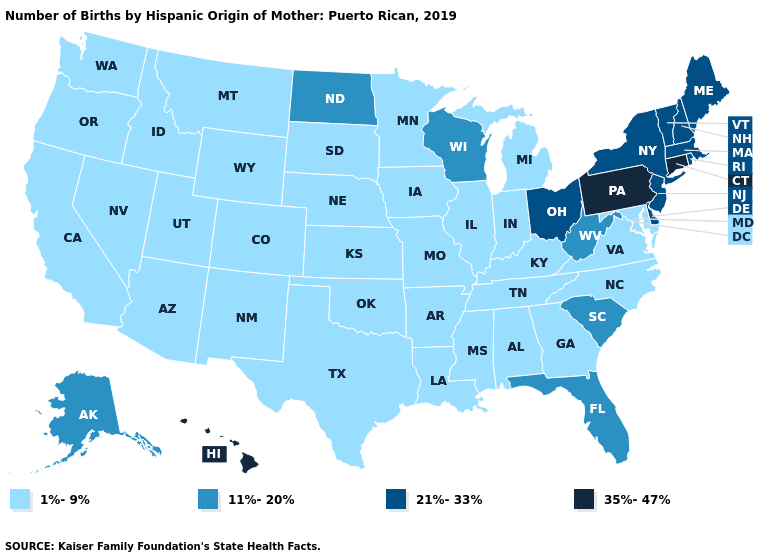What is the lowest value in the MidWest?
Short answer required. 1%-9%. What is the value of Mississippi?
Quick response, please. 1%-9%. Name the states that have a value in the range 11%-20%?
Give a very brief answer. Alaska, Florida, North Dakota, South Carolina, West Virginia, Wisconsin. Does Massachusetts have the lowest value in the Northeast?
Short answer required. Yes. Name the states that have a value in the range 35%-47%?
Keep it brief. Connecticut, Hawaii, Pennsylvania. Which states have the highest value in the USA?
Answer briefly. Connecticut, Hawaii, Pennsylvania. What is the value of Vermont?
Write a very short answer. 21%-33%. Name the states that have a value in the range 1%-9%?
Keep it brief. Alabama, Arizona, Arkansas, California, Colorado, Georgia, Idaho, Illinois, Indiana, Iowa, Kansas, Kentucky, Louisiana, Maryland, Michigan, Minnesota, Mississippi, Missouri, Montana, Nebraska, Nevada, New Mexico, North Carolina, Oklahoma, Oregon, South Dakota, Tennessee, Texas, Utah, Virginia, Washington, Wyoming. What is the highest value in the MidWest ?
Keep it brief. 21%-33%. Does Louisiana have the same value as North Dakota?
Give a very brief answer. No. Which states hav the highest value in the South?
Write a very short answer. Delaware. Does Pennsylvania have the lowest value in the Northeast?
Short answer required. No. Name the states that have a value in the range 35%-47%?
Quick response, please. Connecticut, Hawaii, Pennsylvania. Name the states that have a value in the range 21%-33%?
Write a very short answer. Delaware, Maine, Massachusetts, New Hampshire, New Jersey, New York, Ohio, Rhode Island, Vermont. Among the states that border California , which have the lowest value?
Be succinct. Arizona, Nevada, Oregon. 